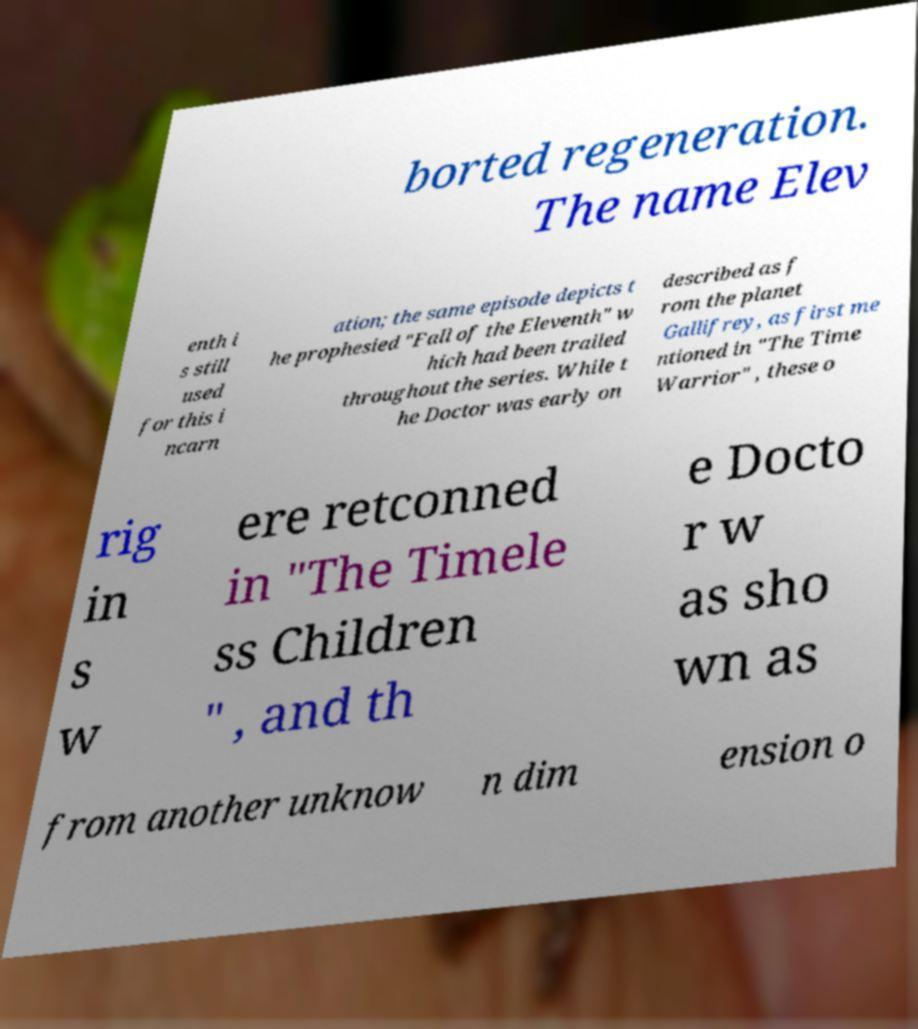Can you read and provide the text displayed in the image?This photo seems to have some interesting text. Can you extract and type it out for me? borted regeneration. The name Elev enth i s still used for this i ncarn ation; the same episode depicts t he prophesied "Fall of the Eleventh" w hich had been trailed throughout the series. While t he Doctor was early on described as f rom the planet Gallifrey, as first me ntioned in "The Time Warrior" , these o rig in s w ere retconned in "The Timele ss Children " , and th e Docto r w as sho wn as from another unknow n dim ension o 